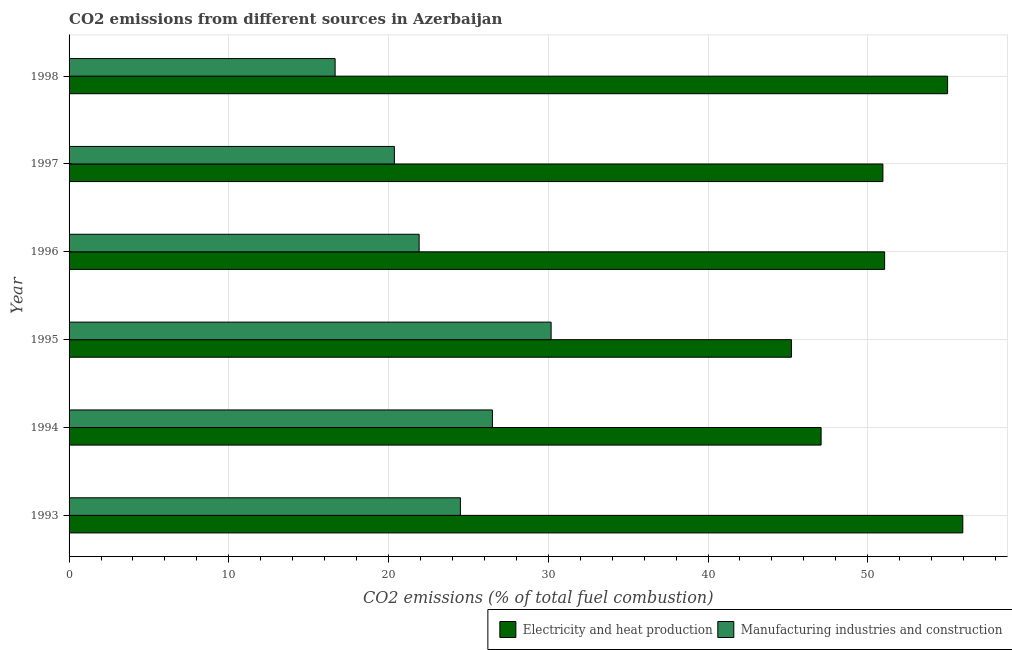How many groups of bars are there?
Ensure brevity in your answer.  6. How many bars are there on the 4th tick from the bottom?
Offer a terse response. 2. What is the label of the 1st group of bars from the top?
Offer a very short reply. 1998. What is the co2 emissions due to electricity and heat production in 1996?
Offer a very short reply. 51.05. Across all years, what is the maximum co2 emissions due to electricity and heat production?
Make the answer very short. 55.95. Across all years, what is the minimum co2 emissions due to electricity and heat production?
Offer a terse response. 45.22. What is the total co2 emissions due to electricity and heat production in the graph?
Ensure brevity in your answer.  305.25. What is the difference between the co2 emissions due to electricity and heat production in 1994 and that in 1996?
Offer a terse response. -3.98. What is the difference between the co2 emissions due to electricity and heat production in 1998 and the co2 emissions due to manufacturing industries in 1993?
Give a very brief answer. 30.5. What is the average co2 emissions due to electricity and heat production per year?
Your response must be concise. 50.87. In the year 1998, what is the difference between the co2 emissions due to manufacturing industries and co2 emissions due to electricity and heat production?
Your response must be concise. -38.34. What is the ratio of the co2 emissions due to electricity and heat production in 1993 to that in 1995?
Your response must be concise. 1.24. Is the co2 emissions due to manufacturing industries in 1993 less than that in 1995?
Ensure brevity in your answer.  Yes. What is the difference between the highest and the second highest co2 emissions due to electricity and heat production?
Provide a short and direct response. 0.95. What is the difference between the highest and the lowest co2 emissions due to electricity and heat production?
Offer a terse response. 10.73. What does the 1st bar from the top in 1994 represents?
Give a very brief answer. Manufacturing industries and construction. What does the 2nd bar from the bottom in 1993 represents?
Provide a short and direct response. Manufacturing industries and construction. How many bars are there?
Give a very brief answer. 12. How many years are there in the graph?
Keep it short and to the point. 6. What is the difference between two consecutive major ticks on the X-axis?
Your answer should be very brief. 10. Are the values on the major ticks of X-axis written in scientific E-notation?
Your answer should be very brief. No. Does the graph contain any zero values?
Provide a succinct answer. No. Does the graph contain grids?
Provide a succinct answer. Yes. Where does the legend appear in the graph?
Ensure brevity in your answer.  Bottom right. What is the title of the graph?
Your response must be concise. CO2 emissions from different sources in Azerbaijan. What is the label or title of the X-axis?
Your answer should be compact. CO2 emissions (% of total fuel combustion). What is the CO2 emissions (% of total fuel combustion) of Electricity and heat production in 1993?
Your answer should be compact. 55.95. What is the CO2 emissions (% of total fuel combustion) of Manufacturing industries and construction in 1993?
Offer a terse response. 24.5. What is the CO2 emissions (% of total fuel combustion) of Electricity and heat production in 1994?
Your answer should be very brief. 47.08. What is the CO2 emissions (% of total fuel combustion) in Manufacturing industries and construction in 1994?
Provide a short and direct response. 26.5. What is the CO2 emissions (% of total fuel combustion) in Electricity and heat production in 1995?
Offer a terse response. 45.22. What is the CO2 emissions (% of total fuel combustion) of Manufacturing industries and construction in 1995?
Your answer should be very brief. 30.18. What is the CO2 emissions (% of total fuel combustion) in Electricity and heat production in 1996?
Your answer should be very brief. 51.05. What is the CO2 emissions (% of total fuel combustion) of Manufacturing industries and construction in 1996?
Offer a very short reply. 21.91. What is the CO2 emissions (% of total fuel combustion) in Electricity and heat production in 1997?
Offer a very short reply. 50.95. What is the CO2 emissions (% of total fuel combustion) in Manufacturing industries and construction in 1997?
Ensure brevity in your answer.  20.36. What is the CO2 emissions (% of total fuel combustion) in Electricity and heat production in 1998?
Your answer should be very brief. 55. What is the CO2 emissions (% of total fuel combustion) in Manufacturing industries and construction in 1998?
Offer a very short reply. 16.66. Across all years, what is the maximum CO2 emissions (% of total fuel combustion) of Electricity and heat production?
Keep it short and to the point. 55.95. Across all years, what is the maximum CO2 emissions (% of total fuel combustion) in Manufacturing industries and construction?
Give a very brief answer. 30.18. Across all years, what is the minimum CO2 emissions (% of total fuel combustion) in Electricity and heat production?
Ensure brevity in your answer.  45.22. Across all years, what is the minimum CO2 emissions (% of total fuel combustion) of Manufacturing industries and construction?
Make the answer very short. 16.66. What is the total CO2 emissions (% of total fuel combustion) of Electricity and heat production in the graph?
Offer a terse response. 305.25. What is the total CO2 emissions (% of total fuel combustion) in Manufacturing industries and construction in the graph?
Provide a succinct answer. 140.11. What is the difference between the CO2 emissions (% of total fuel combustion) in Electricity and heat production in 1993 and that in 1994?
Provide a succinct answer. 8.87. What is the difference between the CO2 emissions (% of total fuel combustion) in Manufacturing industries and construction in 1993 and that in 1994?
Your response must be concise. -2. What is the difference between the CO2 emissions (% of total fuel combustion) of Electricity and heat production in 1993 and that in 1995?
Your answer should be compact. 10.73. What is the difference between the CO2 emissions (% of total fuel combustion) in Manufacturing industries and construction in 1993 and that in 1995?
Provide a short and direct response. -5.68. What is the difference between the CO2 emissions (% of total fuel combustion) in Electricity and heat production in 1993 and that in 1996?
Ensure brevity in your answer.  4.89. What is the difference between the CO2 emissions (% of total fuel combustion) of Manufacturing industries and construction in 1993 and that in 1996?
Your response must be concise. 2.58. What is the difference between the CO2 emissions (% of total fuel combustion) of Electricity and heat production in 1993 and that in 1997?
Offer a very short reply. 5. What is the difference between the CO2 emissions (% of total fuel combustion) of Manufacturing industries and construction in 1993 and that in 1997?
Keep it short and to the point. 4.13. What is the difference between the CO2 emissions (% of total fuel combustion) of Electricity and heat production in 1993 and that in 1998?
Provide a short and direct response. 0.95. What is the difference between the CO2 emissions (% of total fuel combustion) in Manufacturing industries and construction in 1993 and that in 1998?
Provide a succinct answer. 7.84. What is the difference between the CO2 emissions (% of total fuel combustion) of Electricity and heat production in 1994 and that in 1995?
Your response must be concise. 1.86. What is the difference between the CO2 emissions (% of total fuel combustion) in Manufacturing industries and construction in 1994 and that in 1995?
Your answer should be compact. -3.67. What is the difference between the CO2 emissions (% of total fuel combustion) of Electricity and heat production in 1994 and that in 1996?
Provide a succinct answer. -3.98. What is the difference between the CO2 emissions (% of total fuel combustion) of Manufacturing industries and construction in 1994 and that in 1996?
Your answer should be compact. 4.59. What is the difference between the CO2 emissions (% of total fuel combustion) in Electricity and heat production in 1994 and that in 1997?
Your response must be concise. -3.87. What is the difference between the CO2 emissions (% of total fuel combustion) of Manufacturing industries and construction in 1994 and that in 1997?
Offer a terse response. 6.14. What is the difference between the CO2 emissions (% of total fuel combustion) in Electricity and heat production in 1994 and that in 1998?
Provide a succinct answer. -7.92. What is the difference between the CO2 emissions (% of total fuel combustion) in Manufacturing industries and construction in 1994 and that in 1998?
Keep it short and to the point. 9.85. What is the difference between the CO2 emissions (% of total fuel combustion) of Electricity and heat production in 1995 and that in 1996?
Offer a terse response. -5.83. What is the difference between the CO2 emissions (% of total fuel combustion) of Manufacturing industries and construction in 1995 and that in 1996?
Give a very brief answer. 8.26. What is the difference between the CO2 emissions (% of total fuel combustion) in Electricity and heat production in 1995 and that in 1997?
Give a very brief answer. -5.73. What is the difference between the CO2 emissions (% of total fuel combustion) of Manufacturing industries and construction in 1995 and that in 1997?
Your response must be concise. 9.81. What is the difference between the CO2 emissions (% of total fuel combustion) of Electricity and heat production in 1995 and that in 1998?
Your answer should be compact. -9.78. What is the difference between the CO2 emissions (% of total fuel combustion) in Manufacturing industries and construction in 1995 and that in 1998?
Your response must be concise. 13.52. What is the difference between the CO2 emissions (% of total fuel combustion) in Electricity and heat production in 1996 and that in 1997?
Keep it short and to the point. 0.11. What is the difference between the CO2 emissions (% of total fuel combustion) of Manufacturing industries and construction in 1996 and that in 1997?
Provide a succinct answer. 1.55. What is the difference between the CO2 emissions (% of total fuel combustion) in Electricity and heat production in 1996 and that in 1998?
Offer a very short reply. -3.94. What is the difference between the CO2 emissions (% of total fuel combustion) in Manufacturing industries and construction in 1996 and that in 1998?
Provide a succinct answer. 5.26. What is the difference between the CO2 emissions (% of total fuel combustion) of Electricity and heat production in 1997 and that in 1998?
Keep it short and to the point. -4.05. What is the difference between the CO2 emissions (% of total fuel combustion) in Manufacturing industries and construction in 1997 and that in 1998?
Offer a terse response. 3.71. What is the difference between the CO2 emissions (% of total fuel combustion) of Electricity and heat production in 1993 and the CO2 emissions (% of total fuel combustion) of Manufacturing industries and construction in 1994?
Your response must be concise. 29.45. What is the difference between the CO2 emissions (% of total fuel combustion) in Electricity and heat production in 1993 and the CO2 emissions (% of total fuel combustion) in Manufacturing industries and construction in 1995?
Your response must be concise. 25.77. What is the difference between the CO2 emissions (% of total fuel combustion) in Electricity and heat production in 1993 and the CO2 emissions (% of total fuel combustion) in Manufacturing industries and construction in 1996?
Make the answer very short. 34.03. What is the difference between the CO2 emissions (% of total fuel combustion) of Electricity and heat production in 1993 and the CO2 emissions (% of total fuel combustion) of Manufacturing industries and construction in 1997?
Offer a terse response. 35.58. What is the difference between the CO2 emissions (% of total fuel combustion) in Electricity and heat production in 1993 and the CO2 emissions (% of total fuel combustion) in Manufacturing industries and construction in 1998?
Provide a short and direct response. 39.29. What is the difference between the CO2 emissions (% of total fuel combustion) in Electricity and heat production in 1994 and the CO2 emissions (% of total fuel combustion) in Manufacturing industries and construction in 1995?
Keep it short and to the point. 16.9. What is the difference between the CO2 emissions (% of total fuel combustion) of Electricity and heat production in 1994 and the CO2 emissions (% of total fuel combustion) of Manufacturing industries and construction in 1996?
Keep it short and to the point. 25.16. What is the difference between the CO2 emissions (% of total fuel combustion) in Electricity and heat production in 1994 and the CO2 emissions (% of total fuel combustion) in Manufacturing industries and construction in 1997?
Ensure brevity in your answer.  26.71. What is the difference between the CO2 emissions (% of total fuel combustion) in Electricity and heat production in 1994 and the CO2 emissions (% of total fuel combustion) in Manufacturing industries and construction in 1998?
Make the answer very short. 30.42. What is the difference between the CO2 emissions (% of total fuel combustion) of Electricity and heat production in 1995 and the CO2 emissions (% of total fuel combustion) of Manufacturing industries and construction in 1996?
Make the answer very short. 23.31. What is the difference between the CO2 emissions (% of total fuel combustion) in Electricity and heat production in 1995 and the CO2 emissions (% of total fuel combustion) in Manufacturing industries and construction in 1997?
Provide a short and direct response. 24.86. What is the difference between the CO2 emissions (% of total fuel combustion) in Electricity and heat production in 1995 and the CO2 emissions (% of total fuel combustion) in Manufacturing industries and construction in 1998?
Your response must be concise. 28.57. What is the difference between the CO2 emissions (% of total fuel combustion) of Electricity and heat production in 1996 and the CO2 emissions (% of total fuel combustion) of Manufacturing industries and construction in 1997?
Give a very brief answer. 30.69. What is the difference between the CO2 emissions (% of total fuel combustion) in Electricity and heat production in 1996 and the CO2 emissions (% of total fuel combustion) in Manufacturing industries and construction in 1998?
Your response must be concise. 34.4. What is the difference between the CO2 emissions (% of total fuel combustion) in Electricity and heat production in 1997 and the CO2 emissions (% of total fuel combustion) in Manufacturing industries and construction in 1998?
Offer a terse response. 34.29. What is the average CO2 emissions (% of total fuel combustion) of Electricity and heat production per year?
Ensure brevity in your answer.  50.87. What is the average CO2 emissions (% of total fuel combustion) in Manufacturing industries and construction per year?
Your response must be concise. 23.35. In the year 1993, what is the difference between the CO2 emissions (% of total fuel combustion) in Electricity and heat production and CO2 emissions (% of total fuel combustion) in Manufacturing industries and construction?
Your answer should be compact. 31.45. In the year 1994, what is the difference between the CO2 emissions (% of total fuel combustion) of Electricity and heat production and CO2 emissions (% of total fuel combustion) of Manufacturing industries and construction?
Your answer should be compact. 20.58. In the year 1995, what is the difference between the CO2 emissions (% of total fuel combustion) in Electricity and heat production and CO2 emissions (% of total fuel combustion) in Manufacturing industries and construction?
Offer a very short reply. 15.04. In the year 1996, what is the difference between the CO2 emissions (% of total fuel combustion) of Electricity and heat production and CO2 emissions (% of total fuel combustion) of Manufacturing industries and construction?
Keep it short and to the point. 29.14. In the year 1997, what is the difference between the CO2 emissions (% of total fuel combustion) of Electricity and heat production and CO2 emissions (% of total fuel combustion) of Manufacturing industries and construction?
Give a very brief answer. 30.58. In the year 1998, what is the difference between the CO2 emissions (% of total fuel combustion) in Electricity and heat production and CO2 emissions (% of total fuel combustion) in Manufacturing industries and construction?
Ensure brevity in your answer.  38.34. What is the ratio of the CO2 emissions (% of total fuel combustion) of Electricity and heat production in 1993 to that in 1994?
Offer a terse response. 1.19. What is the ratio of the CO2 emissions (% of total fuel combustion) in Manufacturing industries and construction in 1993 to that in 1994?
Offer a terse response. 0.92. What is the ratio of the CO2 emissions (% of total fuel combustion) of Electricity and heat production in 1993 to that in 1995?
Your answer should be compact. 1.24. What is the ratio of the CO2 emissions (% of total fuel combustion) in Manufacturing industries and construction in 1993 to that in 1995?
Provide a succinct answer. 0.81. What is the ratio of the CO2 emissions (% of total fuel combustion) of Electricity and heat production in 1993 to that in 1996?
Keep it short and to the point. 1.1. What is the ratio of the CO2 emissions (% of total fuel combustion) in Manufacturing industries and construction in 1993 to that in 1996?
Your response must be concise. 1.12. What is the ratio of the CO2 emissions (% of total fuel combustion) in Electricity and heat production in 1993 to that in 1997?
Your answer should be compact. 1.1. What is the ratio of the CO2 emissions (% of total fuel combustion) in Manufacturing industries and construction in 1993 to that in 1997?
Keep it short and to the point. 1.2. What is the ratio of the CO2 emissions (% of total fuel combustion) in Electricity and heat production in 1993 to that in 1998?
Offer a very short reply. 1.02. What is the ratio of the CO2 emissions (% of total fuel combustion) in Manufacturing industries and construction in 1993 to that in 1998?
Ensure brevity in your answer.  1.47. What is the ratio of the CO2 emissions (% of total fuel combustion) in Electricity and heat production in 1994 to that in 1995?
Offer a very short reply. 1.04. What is the ratio of the CO2 emissions (% of total fuel combustion) in Manufacturing industries and construction in 1994 to that in 1995?
Offer a terse response. 0.88. What is the ratio of the CO2 emissions (% of total fuel combustion) of Electricity and heat production in 1994 to that in 1996?
Offer a very short reply. 0.92. What is the ratio of the CO2 emissions (% of total fuel combustion) of Manufacturing industries and construction in 1994 to that in 1996?
Offer a terse response. 1.21. What is the ratio of the CO2 emissions (% of total fuel combustion) of Electricity and heat production in 1994 to that in 1997?
Offer a very short reply. 0.92. What is the ratio of the CO2 emissions (% of total fuel combustion) in Manufacturing industries and construction in 1994 to that in 1997?
Your response must be concise. 1.3. What is the ratio of the CO2 emissions (% of total fuel combustion) of Electricity and heat production in 1994 to that in 1998?
Offer a terse response. 0.86. What is the ratio of the CO2 emissions (% of total fuel combustion) in Manufacturing industries and construction in 1994 to that in 1998?
Give a very brief answer. 1.59. What is the ratio of the CO2 emissions (% of total fuel combustion) in Electricity and heat production in 1995 to that in 1996?
Provide a succinct answer. 0.89. What is the ratio of the CO2 emissions (% of total fuel combustion) in Manufacturing industries and construction in 1995 to that in 1996?
Provide a succinct answer. 1.38. What is the ratio of the CO2 emissions (% of total fuel combustion) of Electricity and heat production in 1995 to that in 1997?
Your answer should be compact. 0.89. What is the ratio of the CO2 emissions (% of total fuel combustion) in Manufacturing industries and construction in 1995 to that in 1997?
Provide a short and direct response. 1.48. What is the ratio of the CO2 emissions (% of total fuel combustion) of Electricity and heat production in 1995 to that in 1998?
Offer a very short reply. 0.82. What is the ratio of the CO2 emissions (% of total fuel combustion) in Manufacturing industries and construction in 1995 to that in 1998?
Your answer should be very brief. 1.81. What is the ratio of the CO2 emissions (% of total fuel combustion) of Manufacturing industries and construction in 1996 to that in 1997?
Your answer should be compact. 1.08. What is the ratio of the CO2 emissions (% of total fuel combustion) of Electricity and heat production in 1996 to that in 1998?
Your response must be concise. 0.93. What is the ratio of the CO2 emissions (% of total fuel combustion) of Manufacturing industries and construction in 1996 to that in 1998?
Your answer should be very brief. 1.32. What is the ratio of the CO2 emissions (% of total fuel combustion) of Electricity and heat production in 1997 to that in 1998?
Ensure brevity in your answer.  0.93. What is the ratio of the CO2 emissions (% of total fuel combustion) of Manufacturing industries and construction in 1997 to that in 1998?
Provide a succinct answer. 1.22. What is the difference between the highest and the second highest CO2 emissions (% of total fuel combustion) of Electricity and heat production?
Offer a very short reply. 0.95. What is the difference between the highest and the second highest CO2 emissions (% of total fuel combustion) in Manufacturing industries and construction?
Ensure brevity in your answer.  3.67. What is the difference between the highest and the lowest CO2 emissions (% of total fuel combustion) of Electricity and heat production?
Your response must be concise. 10.73. What is the difference between the highest and the lowest CO2 emissions (% of total fuel combustion) in Manufacturing industries and construction?
Keep it short and to the point. 13.52. 